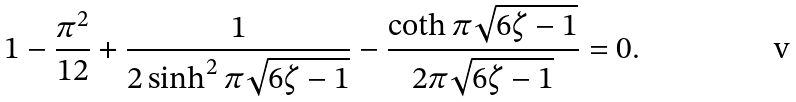<formula> <loc_0><loc_0><loc_500><loc_500>1 - \frac { \pi ^ { 2 } } { 1 2 } + \frac { 1 } { 2 \sinh ^ { 2 } \pi \sqrt { 6 \zeta - 1 } } - \frac { \coth \pi \sqrt { 6 \zeta - 1 } } { 2 \pi \sqrt { 6 \zeta - 1 } } = 0 .</formula> 